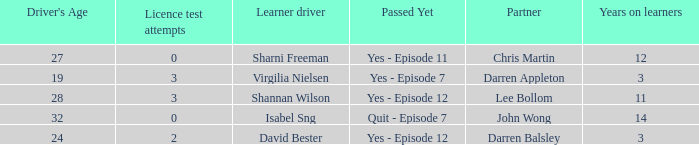What is the average number of years on learners of the drivers over the age of 24 with less than 0 attempts at the licence test? None. 